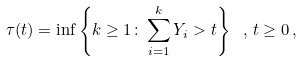<formula> <loc_0><loc_0><loc_500><loc_500>\tau ( t ) = \inf \left \{ k \geq 1 \colon \sum _ { i = 1 } ^ { k } Y _ { i } > t \right \} \ , \, t \geq 0 \, ,</formula> 